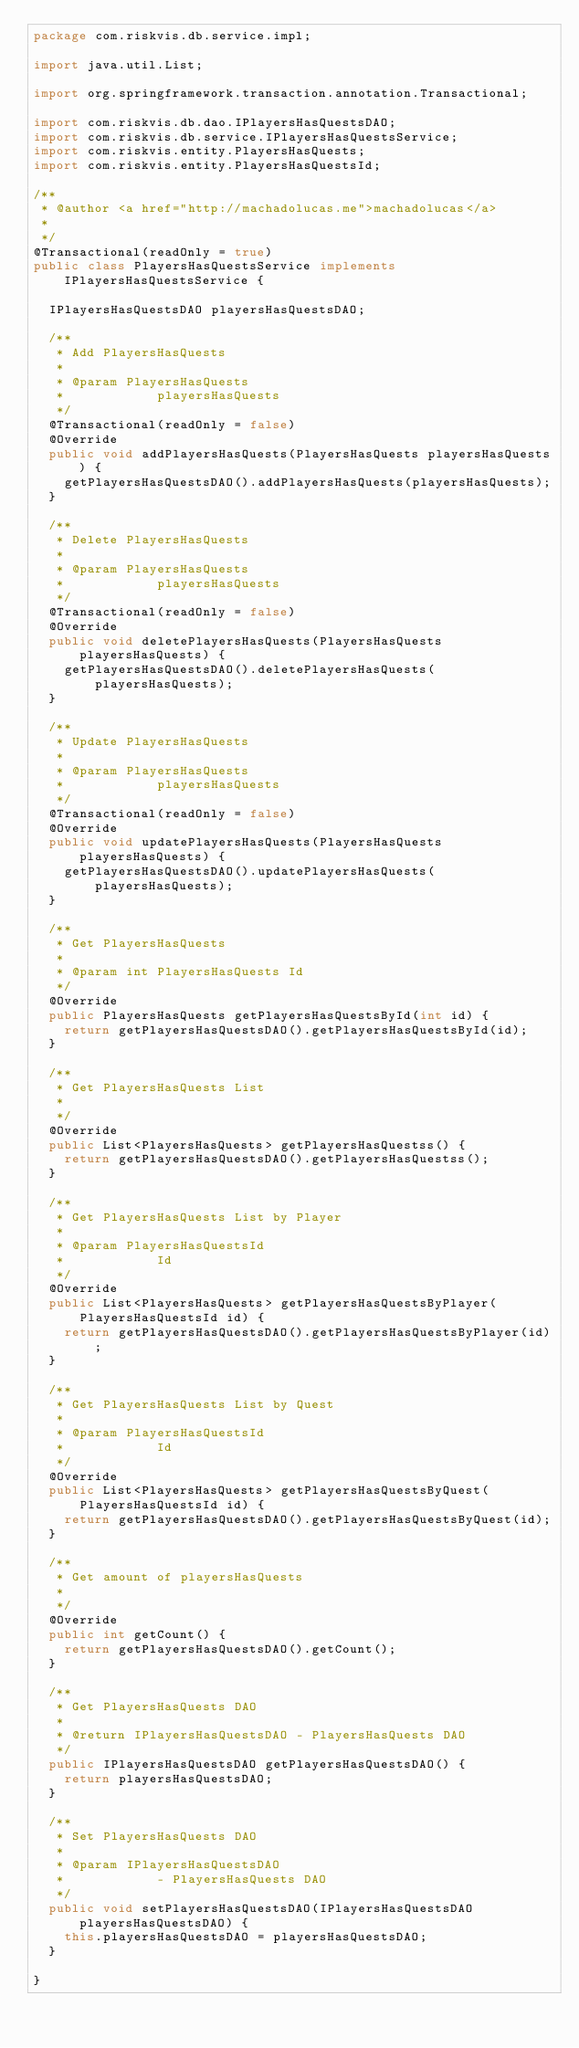<code> <loc_0><loc_0><loc_500><loc_500><_Java_>package com.riskvis.db.service.impl;

import java.util.List;

import org.springframework.transaction.annotation.Transactional;

import com.riskvis.db.dao.IPlayersHasQuestsDAO;
import com.riskvis.db.service.IPlayersHasQuestsService;
import com.riskvis.entity.PlayersHasQuests;
import com.riskvis.entity.PlayersHasQuestsId;

/**
 * @author <a href="http://machadolucas.me">machadolucas</a>
 *
 */
@Transactional(readOnly = true)
public class PlayersHasQuestsService implements IPlayersHasQuestsService {

	IPlayersHasQuestsDAO playersHasQuestsDAO;

	/**
	 * Add PlayersHasQuests
	 *
	 * @param PlayersHasQuests
	 *            playersHasQuests
	 */
	@Transactional(readOnly = false)
	@Override
	public void addPlayersHasQuests(PlayersHasQuests playersHasQuests) {
		getPlayersHasQuestsDAO().addPlayersHasQuests(playersHasQuests);
	}

	/**
	 * Delete PlayersHasQuests
	 *
	 * @param PlayersHasQuests
	 *            playersHasQuests
	 */
	@Transactional(readOnly = false)
	@Override
	public void deletePlayersHasQuests(PlayersHasQuests playersHasQuests) {
		getPlayersHasQuestsDAO().deletePlayersHasQuests(playersHasQuests);
	}

	/**
	 * Update PlayersHasQuests
	 *
	 * @param PlayersHasQuests
	 *            playersHasQuests
	 */
	@Transactional(readOnly = false)
	@Override
	public void updatePlayersHasQuests(PlayersHasQuests playersHasQuests) {
		getPlayersHasQuestsDAO().updatePlayersHasQuests(playersHasQuests);
	}

	/**
	 * Get PlayersHasQuests
	 *
	 * @param int PlayersHasQuests Id
	 */
	@Override
	public PlayersHasQuests getPlayersHasQuestsById(int id) {
		return getPlayersHasQuestsDAO().getPlayersHasQuestsById(id);
	}

	/**
	 * Get PlayersHasQuests List
	 *
	 */
	@Override
	public List<PlayersHasQuests> getPlayersHasQuestss() {
		return getPlayersHasQuestsDAO().getPlayersHasQuestss();
	}

	/**
	 * Get PlayersHasQuests List by Player
	 *
	 * @param PlayersHasQuestsId
	 *            Id
	 */
	@Override
	public List<PlayersHasQuests> getPlayersHasQuestsByPlayer(
			PlayersHasQuestsId id) {
		return getPlayersHasQuestsDAO().getPlayersHasQuestsByPlayer(id);
	}

	/**
	 * Get PlayersHasQuests List by Quest
	 *
	 * @param PlayersHasQuestsId
	 *            Id
	 */
	@Override
	public List<PlayersHasQuests> getPlayersHasQuestsByQuest(
			PlayersHasQuestsId id) {
		return getPlayersHasQuestsDAO().getPlayersHasQuestsByQuest(id);
	}

	/**
	 * Get amount of playersHasQuests
	 *
	 */
	@Override
	public int getCount() {
		return getPlayersHasQuestsDAO().getCount();
	}

	/**
	 * Get PlayersHasQuests DAO
	 *
	 * @return IPlayersHasQuestsDAO - PlayersHasQuests DAO
	 */
	public IPlayersHasQuestsDAO getPlayersHasQuestsDAO() {
		return playersHasQuestsDAO;
	}

	/**
	 * Set PlayersHasQuests DAO
	 *
	 * @param IPlayersHasQuestsDAO
	 *            - PlayersHasQuests DAO
	 */
	public void setPlayersHasQuestsDAO(IPlayersHasQuestsDAO playersHasQuestsDAO) {
		this.playersHasQuestsDAO = playersHasQuestsDAO;
	}

}
</code> 